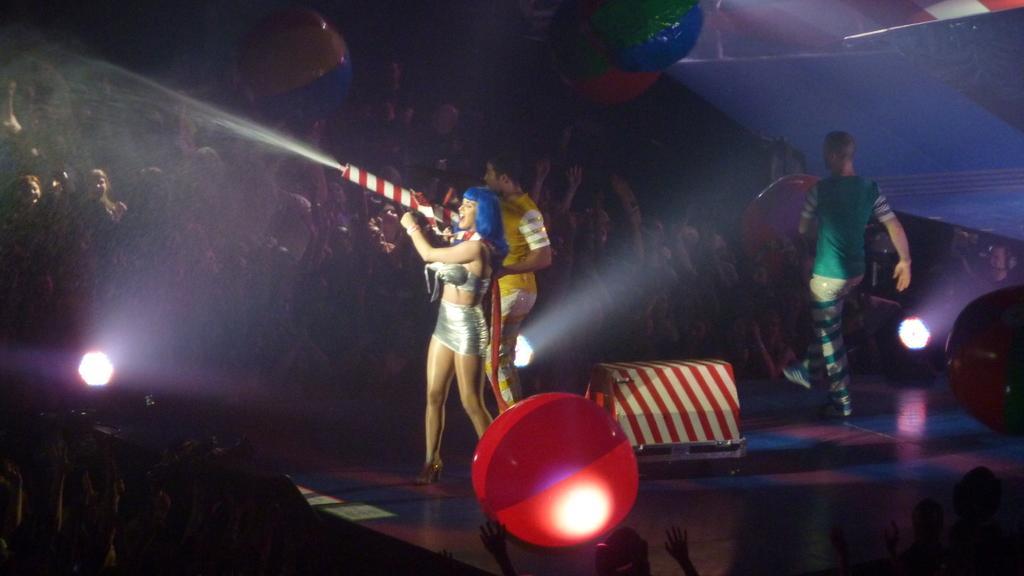Please provide a concise description of this image. In this image we can see a group of people standing on the stage. In that a woman is holding a pole. We can also see a box and some lights beside them. We can also see a group of people and some balls around them. 